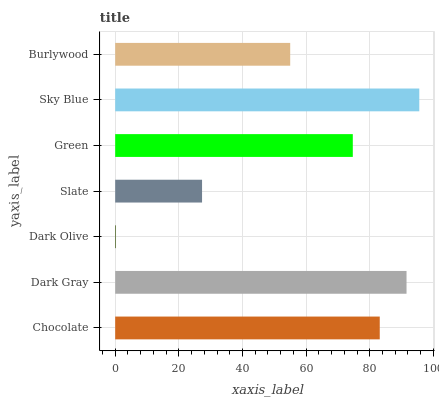Is Dark Olive the minimum?
Answer yes or no. Yes. Is Sky Blue the maximum?
Answer yes or no. Yes. Is Dark Gray the minimum?
Answer yes or no. No. Is Dark Gray the maximum?
Answer yes or no. No. Is Dark Gray greater than Chocolate?
Answer yes or no. Yes. Is Chocolate less than Dark Gray?
Answer yes or no. Yes. Is Chocolate greater than Dark Gray?
Answer yes or no. No. Is Dark Gray less than Chocolate?
Answer yes or no. No. Is Green the high median?
Answer yes or no. Yes. Is Green the low median?
Answer yes or no. Yes. Is Chocolate the high median?
Answer yes or no. No. Is Sky Blue the low median?
Answer yes or no. No. 